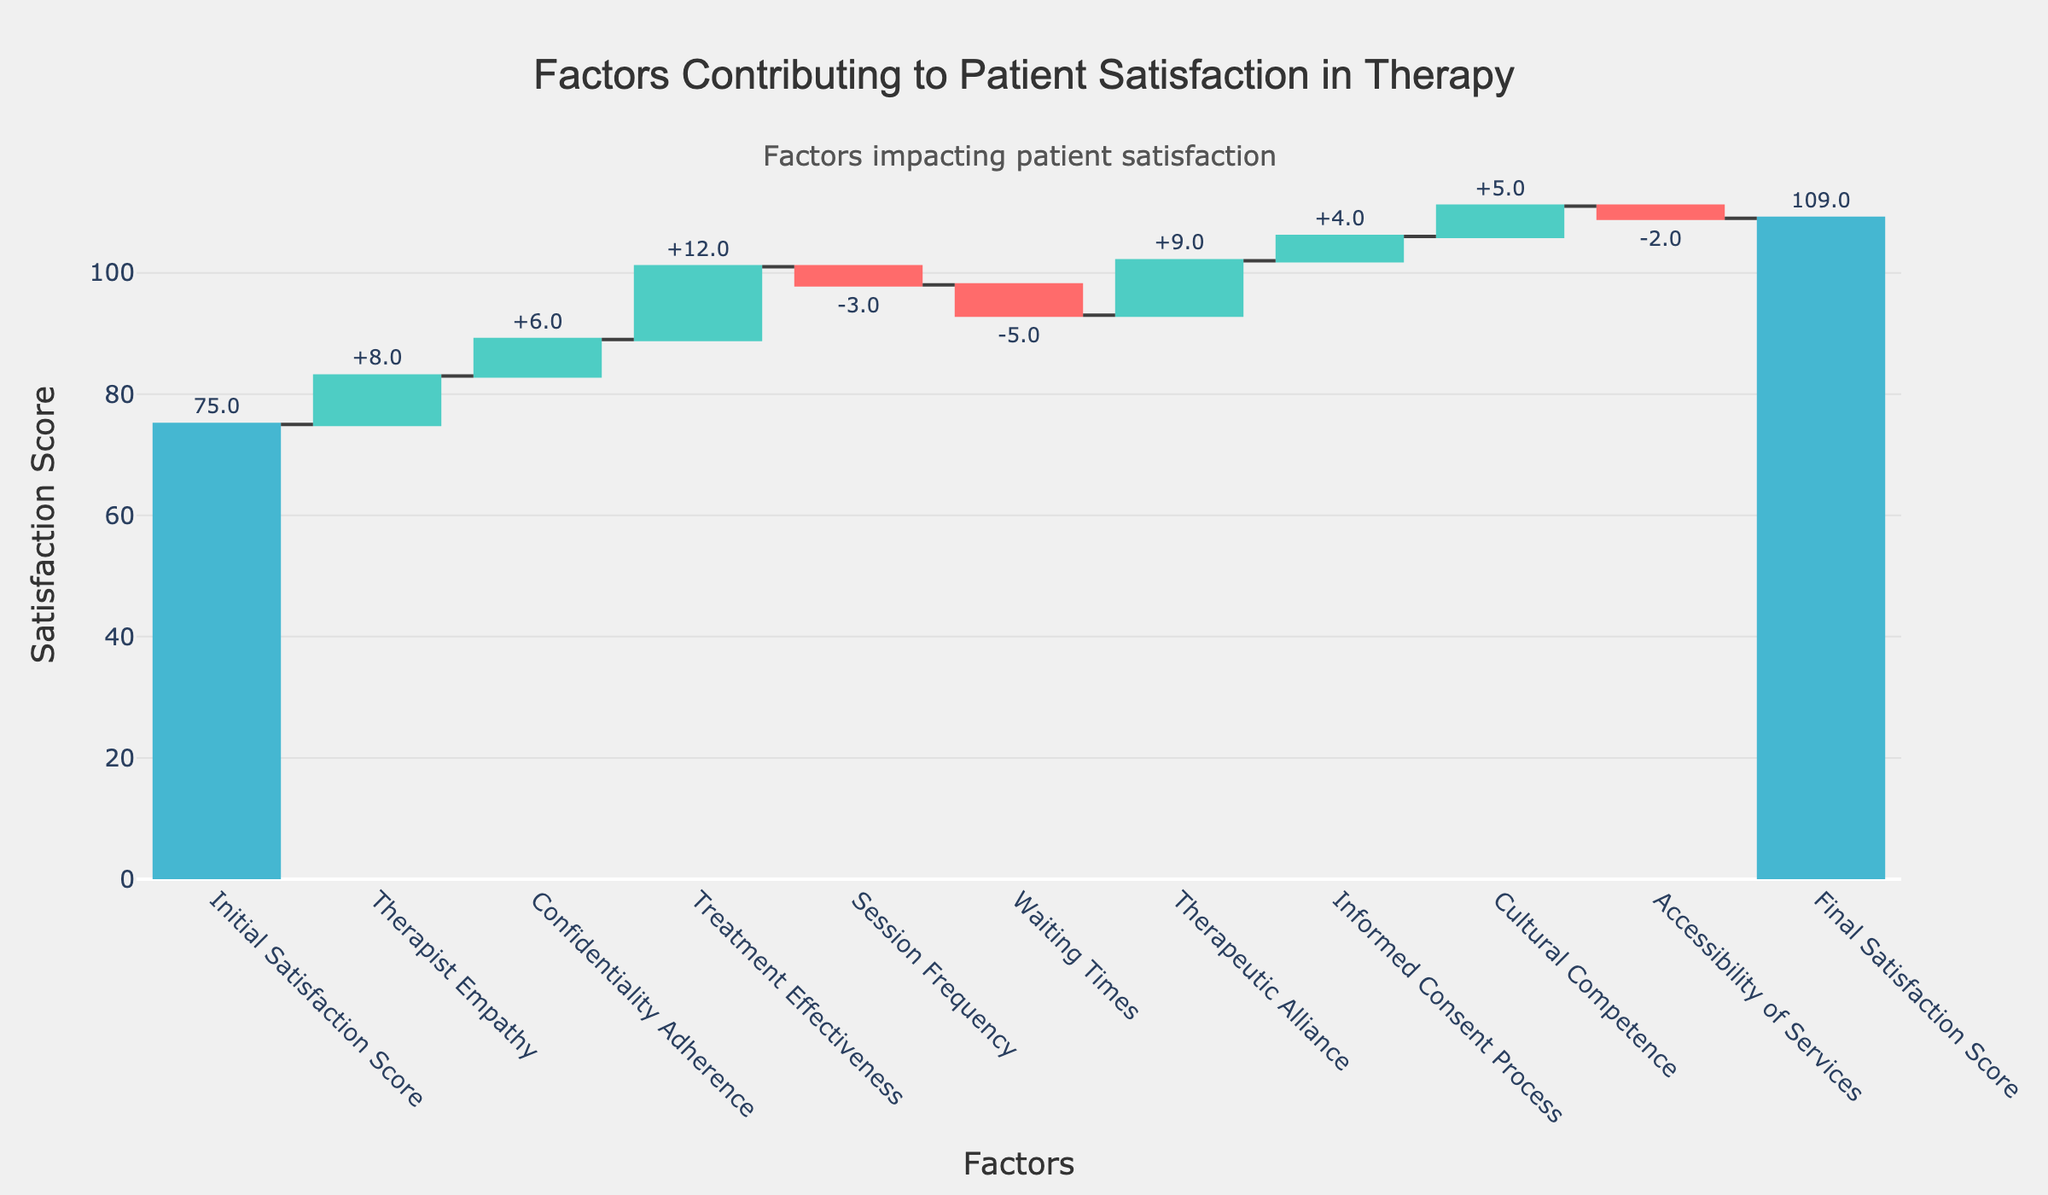What is the title of the chart? The title of the chart is displayed at the top center of the chart in bold. It reads "Factors Contributing to Patient Satisfaction in Therapy".
Answer: Factors Contributing to Patient Satisfaction in Therapy What are the units used on the y-axis? The y-axis is labeled "Satisfaction Score", indicating that the units used to measure the scores are numerical values representing satisfaction levels.
Answer: Satisfaction Score Which single factor contributed the most positively to patient satisfaction? By examining the individual categories, "Treatment Effectiveness" shows the highest positive contribution, with a value of 12.
Answer: Treatment Effectiveness How did "Accessibility of Services" affect overall patient satisfaction? The "Accessibility of Services" has a negative value of -2, indicating that it reduced the overall patient satisfaction score by 2 points.
Answer: Reduced by 2 points What is the net effect of "Session Frequency" and "Waiting Times" combined? Both "Session Frequency" and "Waiting Times" have negative contributions. "Session Frequency" is -3 and "Waiting Times" is -5. Adding these values: -3 + (-5) = -8.
Answer: -8 Identify two factors that have similar magnitudes but opposite effects on satisfaction. "Confidentiality Adherence" and "Waiting Times" both have absolute values around 5-6 but opposite contributions: "Confidentiality Adherence" is +6 and "Waiting Times" is -5.
Answer: Confidentiality Adherence and Waiting Times What is the total increase in satisfaction contributed by positive factors? Positive contributions come from "Therapist Empathy" (+8), "Confidentiality Adherence" (+6), "Treatment Effectiveness" (+12), "Therapeutic Alliance" (+9), "Informed Consent Process" (+4), and "Cultural Competence" (+5). Sum these values: 8 + 6 + 12 + 9 + 4 + 5 = 44.
Answer: 44 What factor contrubuted the most negatively to satisfaction scores? By referring to the negative values, "Waiting Times" shows the most negative contribution with a value of -5.
Answer: Waiting Times Confirm the final satisfaction score based on the initial score and contributions. Starting from the initial score of 75, we add all contributions: +8, +6, +12, -3, -5, +9, +4, +5, -2. The sum is 34, add this to 75 results in a final score of 75 + 34 = 109.
Answer: 109 